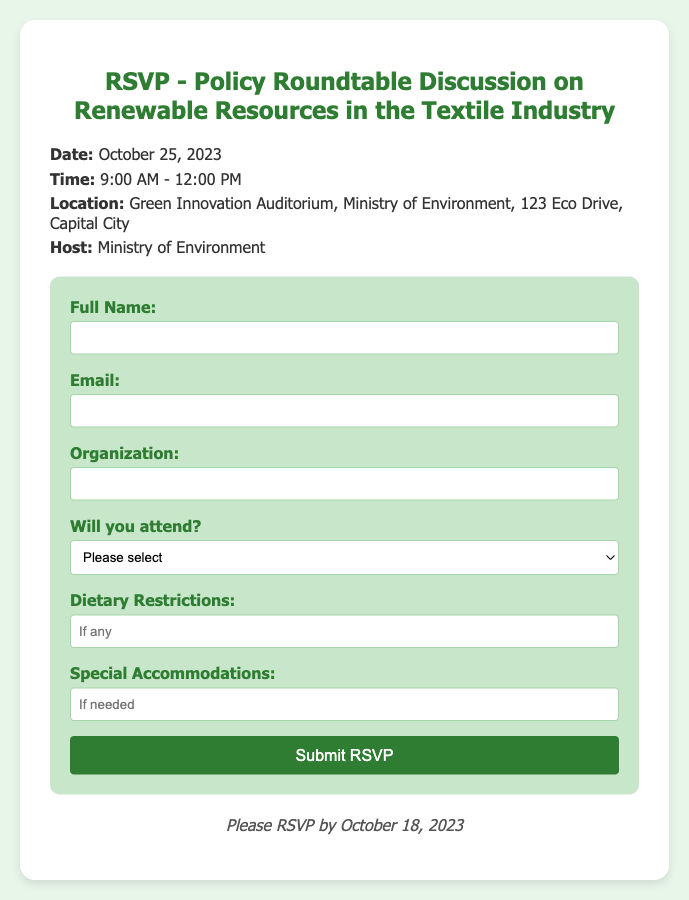What is the date of the event? The date of the event is mentioned in the document under event details.
Answer: October 25, 2023 What time does the event start? The starting time of the event is specified in the document.
Answer: 9:00 AM Where is the event located? The location is provided in the event details section of the document.
Answer: Green Innovation Auditorium, Ministry of Environment, 123 Eco Drive, Capital City What is the deadline to RSVP? The deadline for RSVP is clearly stated in the document.
Answer: October 18, 2023 Who is hosting the event? The document specifies the host organization for the event.
Answer: Ministry of Environment What information is required in the RSVP form? The RSVP form lists the required fields that need to be filled.
Answer: Full Name, Email, Organization, Will you attend? What dietary information is requested in the form? The RSVP form includes a question regarding dietary restrictions.
Answer: Dietary Restrictions What is the purpose of this document? The nature of the document is indicated by the title and contents provided.
Answer: RSVP for Policy Roundtable Discussion 